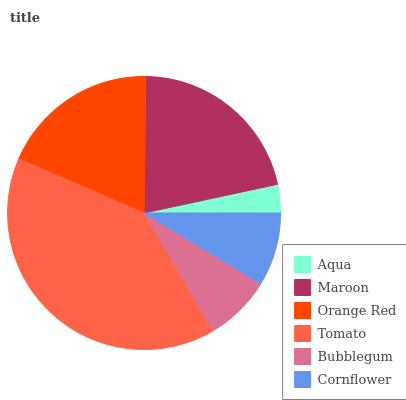Is Aqua the minimum?
Answer yes or no. Yes. Is Tomato the maximum?
Answer yes or no. Yes. Is Maroon the minimum?
Answer yes or no. No. Is Maroon the maximum?
Answer yes or no. No. Is Maroon greater than Aqua?
Answer yes or no. Yes. Is Aqua less than Maroon?
Answer yes or no. Yes. Is Aqua greater than Maroon?
Answer yes or no. No. Is Maroon less than Aqua?
Answer yes or no. No. Is Orange Red the high median?
Answer yes or no. Yes. Is Cornflower the low median?
Answer yes or no. Yes. Is Cornflower the high median?
Answer yes or no. No. Is Tomato the low median?
Answer yes or no. No. 